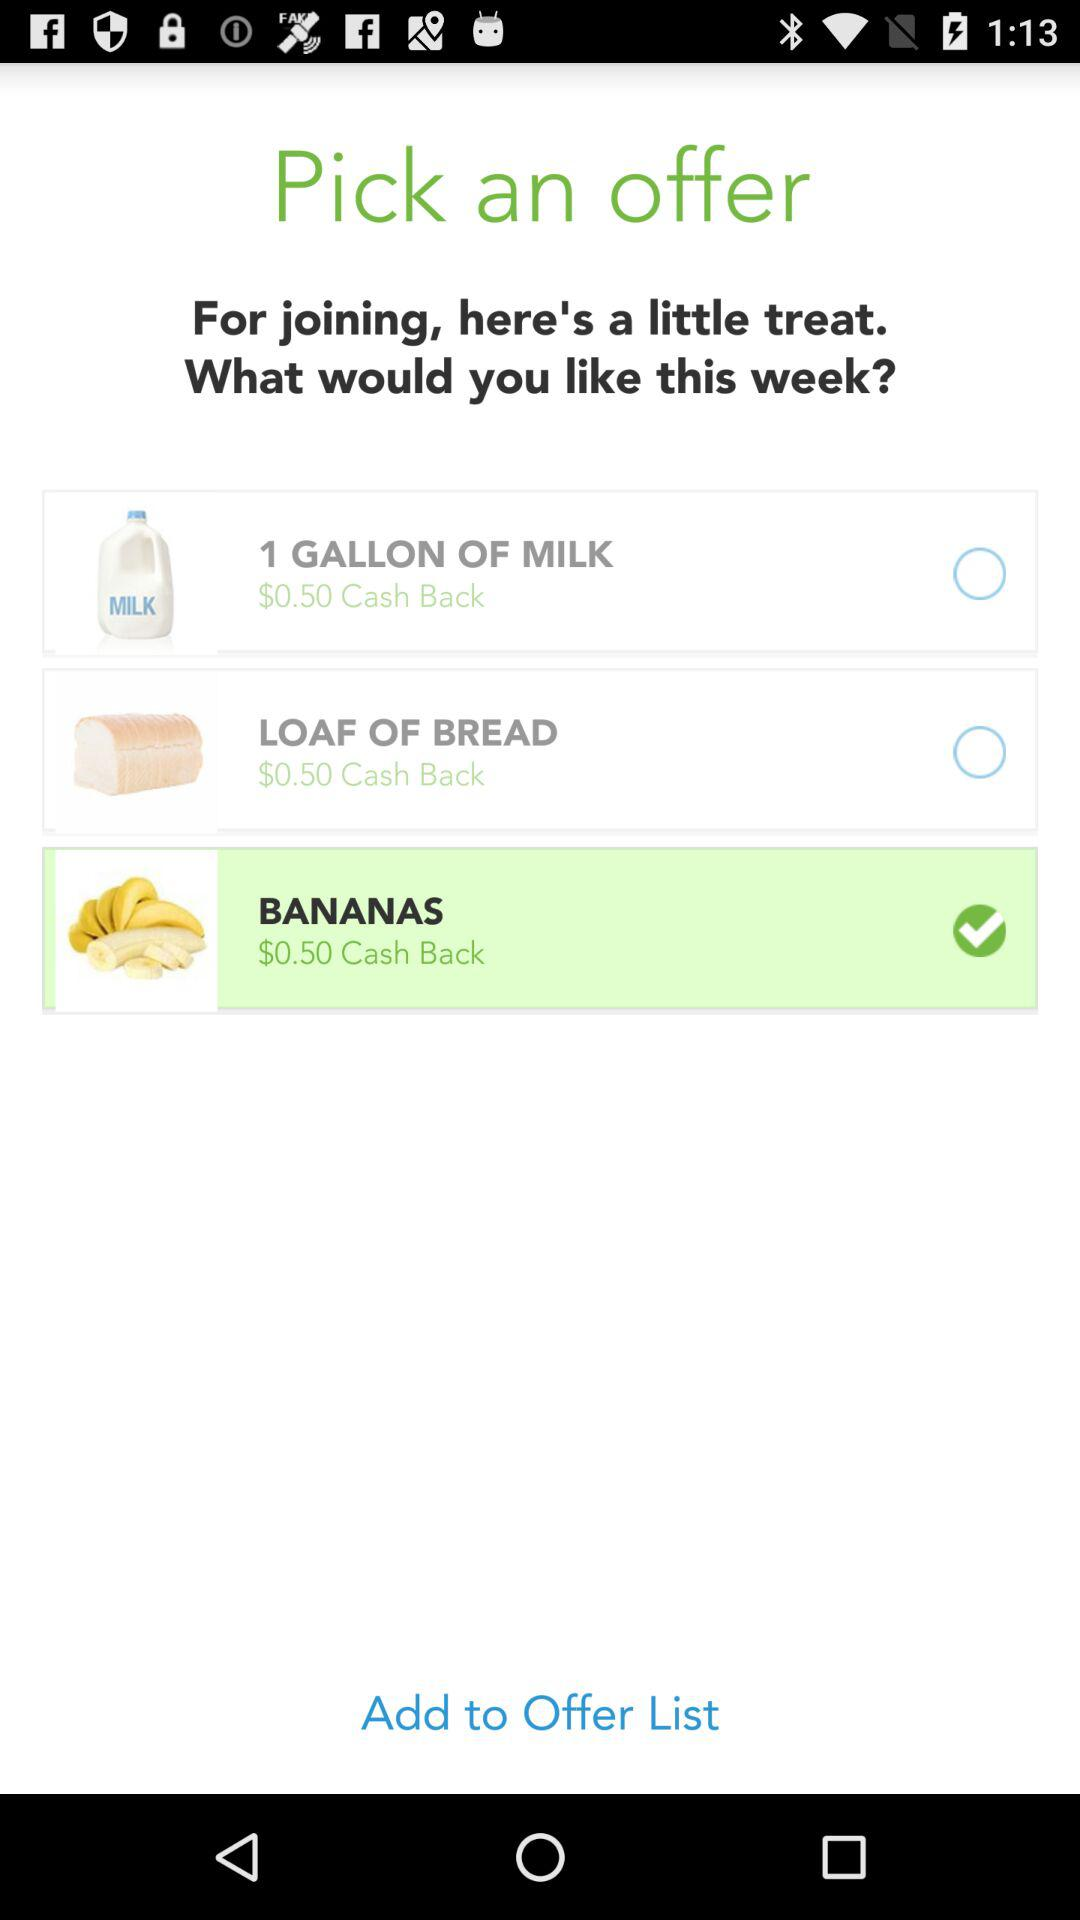What is the currency of the cash back? The currency of the cash back is dollars. 